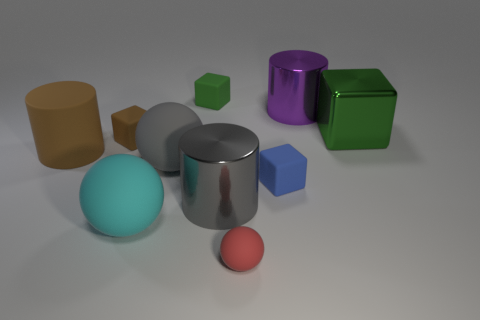There is another matte cube that is the same color as the big cube; what size is it?
Your response must be concise. Small. The tiny rubber thing that is the same color as the large rubber cylinder is what shape?
Make the answer very short. Cube. What is the size of the brown block?
Offer a terse response. Small. What number of cyan things are rubber spheres or big blocks?
Provide a succinct answer. 1. How many large brown rubber things have the same shape as the purple object?
Make the answer very short. 1. How many brown things are the same size as the gray metal object?
Your answer should be compact. 1. What material is the large green thing that is the same shape as the tiny blue object?
Provide a succinct answer. Metal. What is the color of the tiny cube on the left side of the big cyan matte sphere?
Provide a succinct answer. Brown. Is the number of large gray cylinders that are to the left of the red matte sphere greater than the number of red shiny cylinders?
Provide a succinct answer. Yes. What is the color of the tiny ball?
Give a very brief answer. Red. 